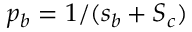Convert formula to latex. <formula><loc_0><loc_0><loc_500><loc_500>p _ { b } = 1 / ( s _ { b } + S _ { c } )</formula> 